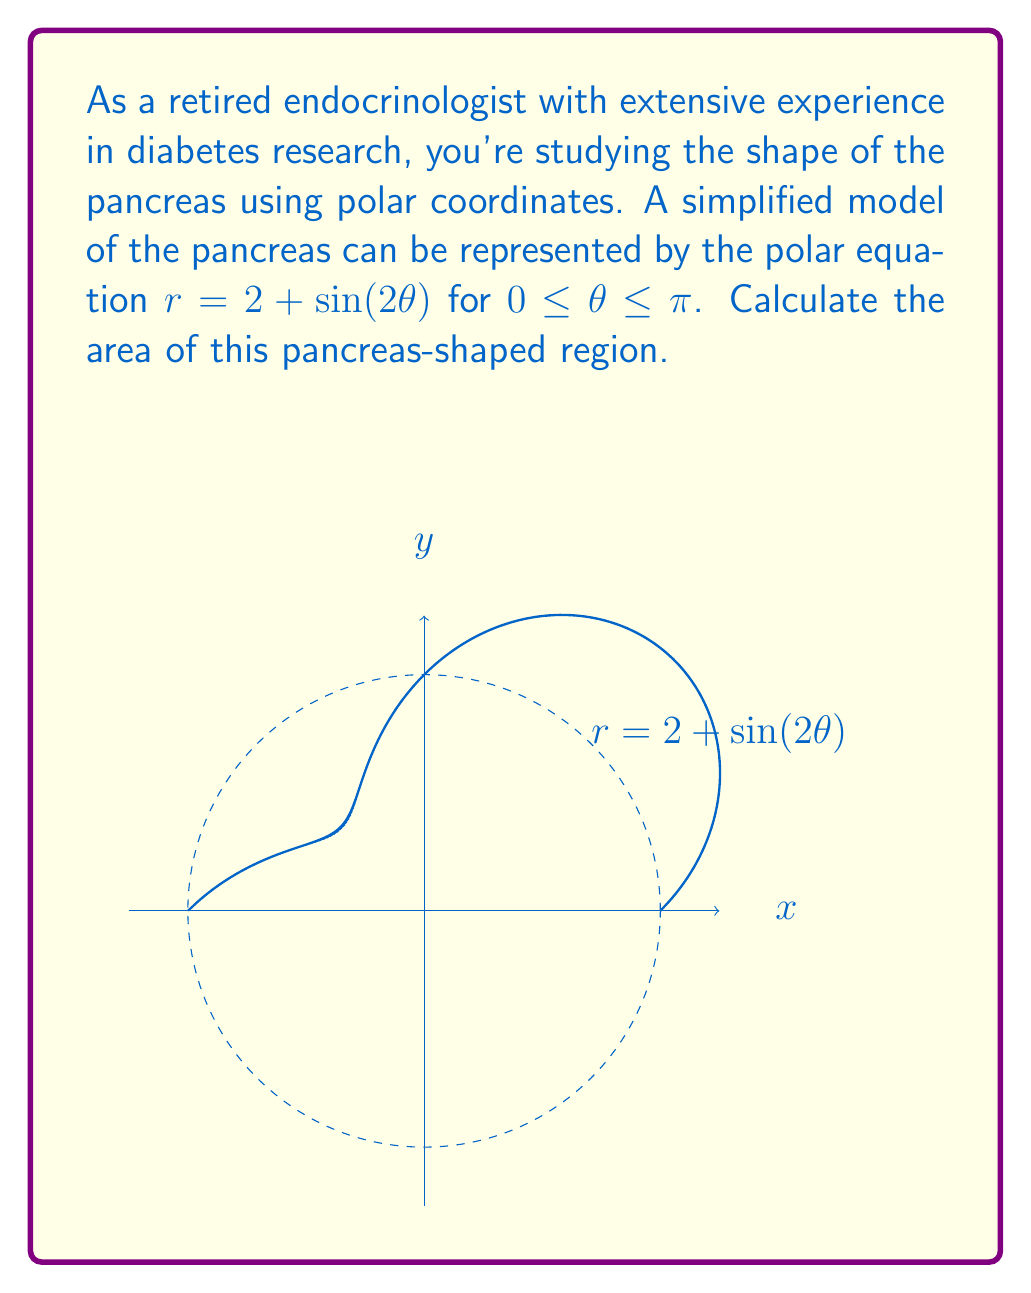Can you solve this math problem? To calculate the area of the region described by the polar equation $r = 2 + \sin(2\theta)$ for $0 \leq \theta \leq \pi$, we'll use the formula for area in polar coordinates:

$$A = \frac{1}{2} \int_a^b [r(\theta)]^2 d\theta$$

Where $a = 0$ and $b = \pi$ in this case.

Step 1: Substitute the given equation into the area formula:
$$A = \frac{1}{2} \int_0^\pi [2 + \sin(2\theta)]^2 d\theta$$

Step 2: Expand the squared term:
$$A = \frac{1}{2} \int_0^\pi [4 + 4\sin(2\theta) + \sin^2(2\theta)] d\theta$$

Step 3: Use the trigonometric identity $\sin^2(2\theta) = \frac{1}{2}[1 - \cos(4\theta)]$:
$$A = \frac{1}{2} \int_0^\pi [4 + 4\sin(2\theta) + \frac{1}{2} - \frac{1}{2}\cos(4\theta)] d\theta$$

Step 4: Simplify:
$$A = \frac{1}{2} \int_0^\pi [4.5 + 4\sin(2\theta) - \frac{1}{2}\cos(4\theta)] d\theta$$

Step 5: Integrate each term:
$$A = \frac{1}{2} [4.5\theta - 2\cos(2\theta) - \frac{1}{8}\sin(4\theta)]_0^\pi$$

Step 6: Evaluate the integral:
$$A = \frac{1}{2} [(4.5\pi - 2\cos(2\pi) - \frac{1}{8}\sin(4\pi)) - (0 - 2\cos(0) - \frac{1}{8}\sin(0))]$$

Step 7: Simplify:
$$A = \frac{1}{2} [4.5\pi - 2 + 2] = \frac{1}{2} [4.5\pi] = 2.25\pi$$

Therefore, the area of the pancreas-shaped region is $2.25\pi$ square units.
Answer: $2.25\pi$ square units 